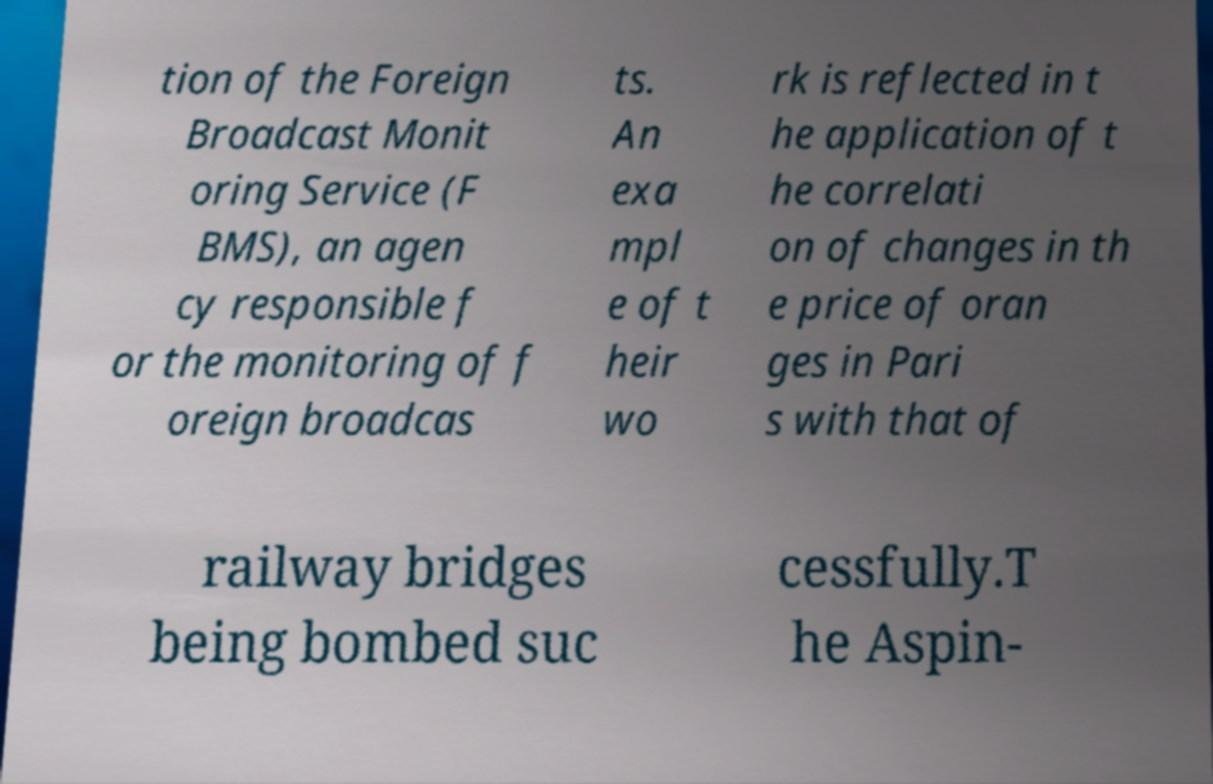Can you read and provide the text displayed in the image?This photo seems to have some interesting text. Can you extract and type it out for me? tion of the Foreign Broadcast Monit oring Service (F BMS), an agen cy responsible f or the monitoring of f oreign broadcas ts. An exa mpl e of t heir wo rk is reflected in t he application of t he correlati on of changes in th e price of oran ges in Pari s with that of railway bridges being bombed suc cessfully.T he Aspin- 